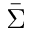<formula> <loc_0><loc_0><loc_500><loc_500>\bar { \Sigma }</formula> 